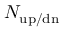Convert formula to latex. <formula><loc_0><loc_0><loc_500><loc_500>N _ { u p / d n }</formula> 